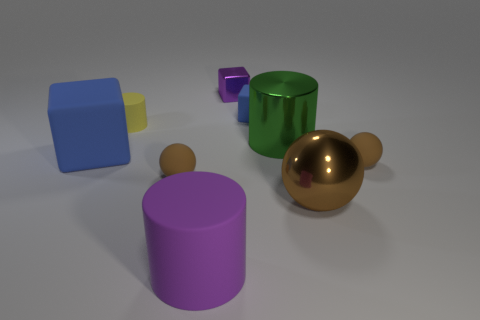Add 1 yellow matte cylinders. How many objects exist? 10 Subtract all cylinders. How many objects are left? 6 Add 4 blue rubber cubes. How many blue rubber cubes exist? 6 Subtract 0 green balls. How many objects are left? 9 Subtract all purple matte objects. Subtract all purple objects. How many objects are left? 6 Add 6 rubber cylinders. How many rubber cylinders are left? 8 